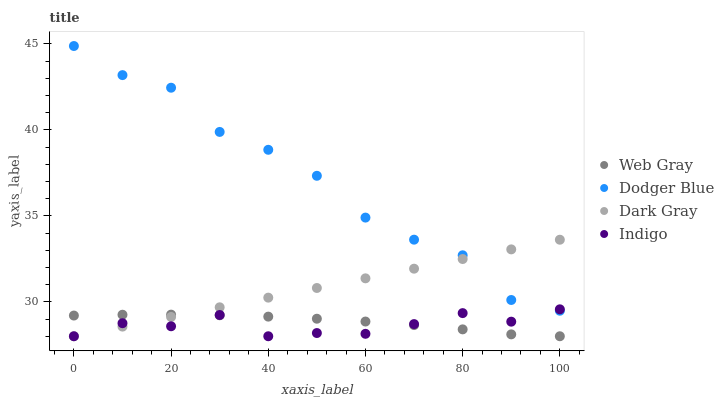Does Indigo have the minimum area under the curve?
Answer yes or no. Yes. Does Dodger Blue have the maximum area under the curve?
Answer yes or no. Yes. Does Web Gray have the minimum area under the curve?
Answer yes or no. No. Does Web Gray have the maximum area under the curve?
Answer yes or no. No. Is Dark Gray the smoothest?
Answer yes or no. Yes. Is Dodger Blue the roughest?
Answer yes or no. Yes. Is Indigo the smoothest?
Answer yes or no. No. Is Indigo the roughest?
Answer yes or no. No. Does Dark Gray have the lowest value?
Answer yes or no. Yes. Does Dodger Blue have the lowest value?
Answer yes or no. No. Does Dodger Blue have the highest value?
Answer yes or no. Yes. Does Indigo have the highest value?
Answer yes or no. No. Is Web Gray less than Dodger Blue?
Answer yes or no. Yes. Is Dodger Blue greater than Web Gray?
Answer yes or no. Yes. Does Indigo intersect Web Gray?
Answer yes or no. Yes. Is Indigo less than Web Gray?
Answer yes or no. No. Is Indigo greater than Web Gray?
Answer yes or no. No. Does Web Gray intersect Dodger Blue?
Answer yes or no. No. 